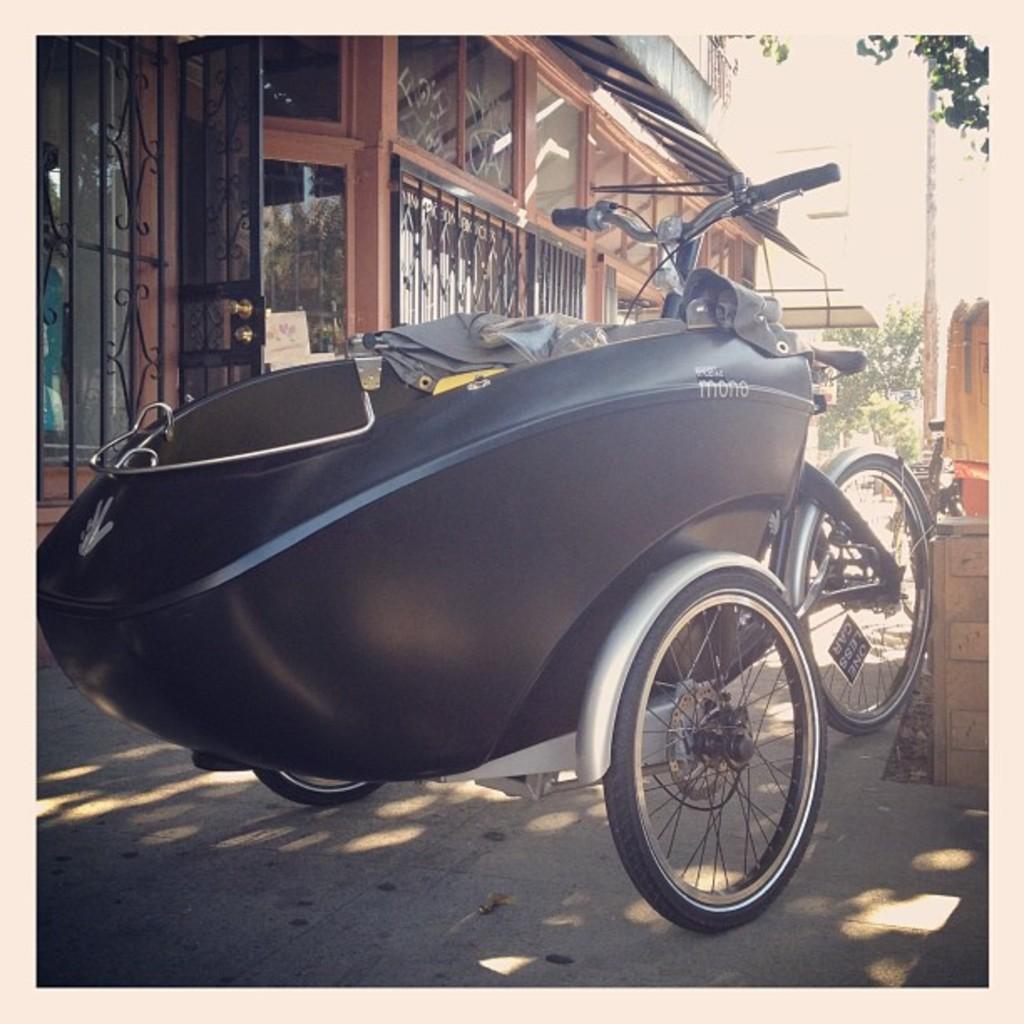Can you describe this image briefly? In this image, we can see a vehicle and the ground. We can see some buildings and a pole. There are a few trees. 